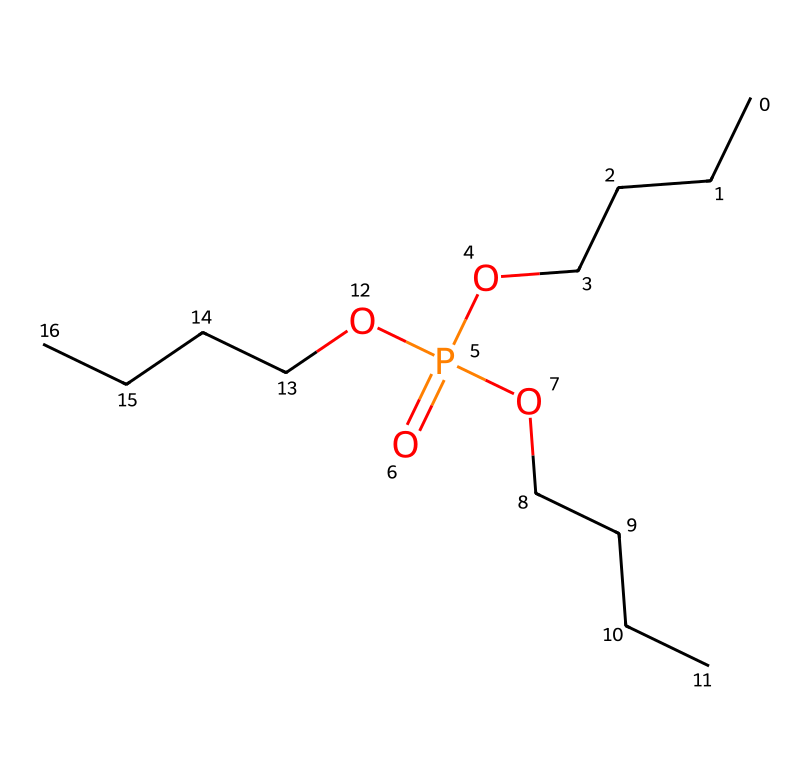What is the common name of this chemical? The SMILES representation corresponds to tributyl phosphate, which is a well-known chemical used as a flame retardant and plasticizer.
Answer: tributyl phosphate How many phosphorus atoms are present in this compound? The chemical structure includes one phosphorus atom, as indicated by the "P" in the SMILES notation.
Answer: one What is the main functional group observed in this chemical? The presence of the phosphate group is evident from the "P(=O)(O...)" part of the SMILES, which indicates a phosphorus atom bonded to oxygen atoms.
Answer: phosphate How many butyl groups are attached to the phosphorus atom? In the SMILES representation, there are three instances of "OCCCC" which indicates three butyl groups attached to phosphorus.
Answer: three What type of chemical interaction is primarily associated with tributyl phosphate? This compound is known for its polar characteristics due to the phosphate group, allowing for hydrogen bonding and interactions with polar solvents.
Answer: hydrogen bonding What is the total number of oxygen atoms in tributyl phosphate? The structure shows a total of four oxygen atoms; one is part of the phosphate group (P=O) and the three are the oxygens connecting the butyl groups.
Answer: four 